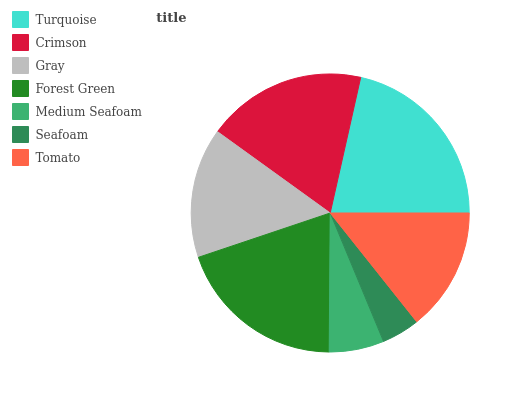Is Seafoam the minimum?
Answer yes or no. Yes. Is Turquoise the maximum?
Answer yes or no. Yes. Is Crimson the minimum?
Answer yes or no. No. Is Crimson the maximum?
Answer yes or no. No. Is Turquoise greater than Crimson?
Answer yes or no. Yes. Is Crimson less than Turquoise?
Answer yes or no. Yes. Is Crimson greater than Turquoise?
Answer yes or no. No. Is Turquoise less than Crimson?
Answer yes or no. No. Is Gray the high median?
Answer yes or no. Yes. Is Gray the low median?
Answer yes or no. Yes. Is Tomato the high median?
Answer yes or no. No. Is Forest Green the low median?
Answer yes or no. No. 